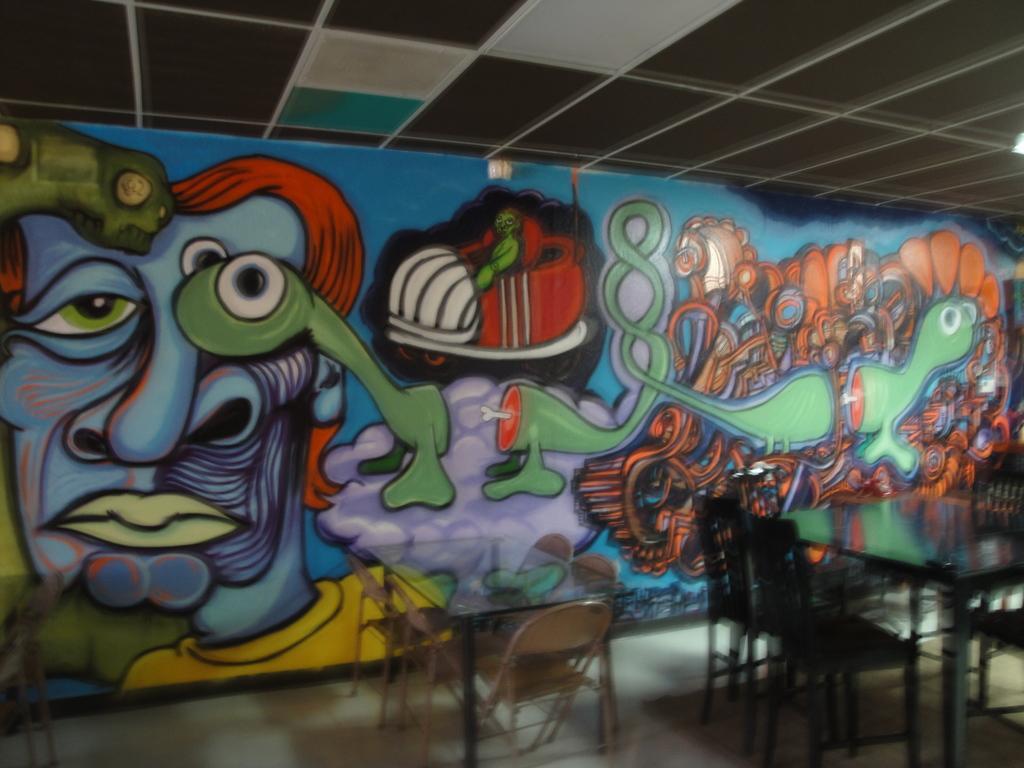How would you summarize this image in a sentence or two? In this picture we can see few tables and chairs, beside to the tables we can find painting on the wall. 